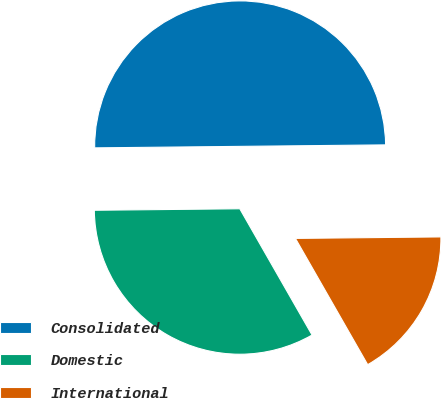Convert chart to OTSL. <chart><loc_0><loc_0><loc_500><loc_500><pie_chart><fcel>Consolidated<fcel>Domestic<fcel>International<nl><fcel>50.0%<fcel>33.11%<fcel>16.89%<nl></chart> 